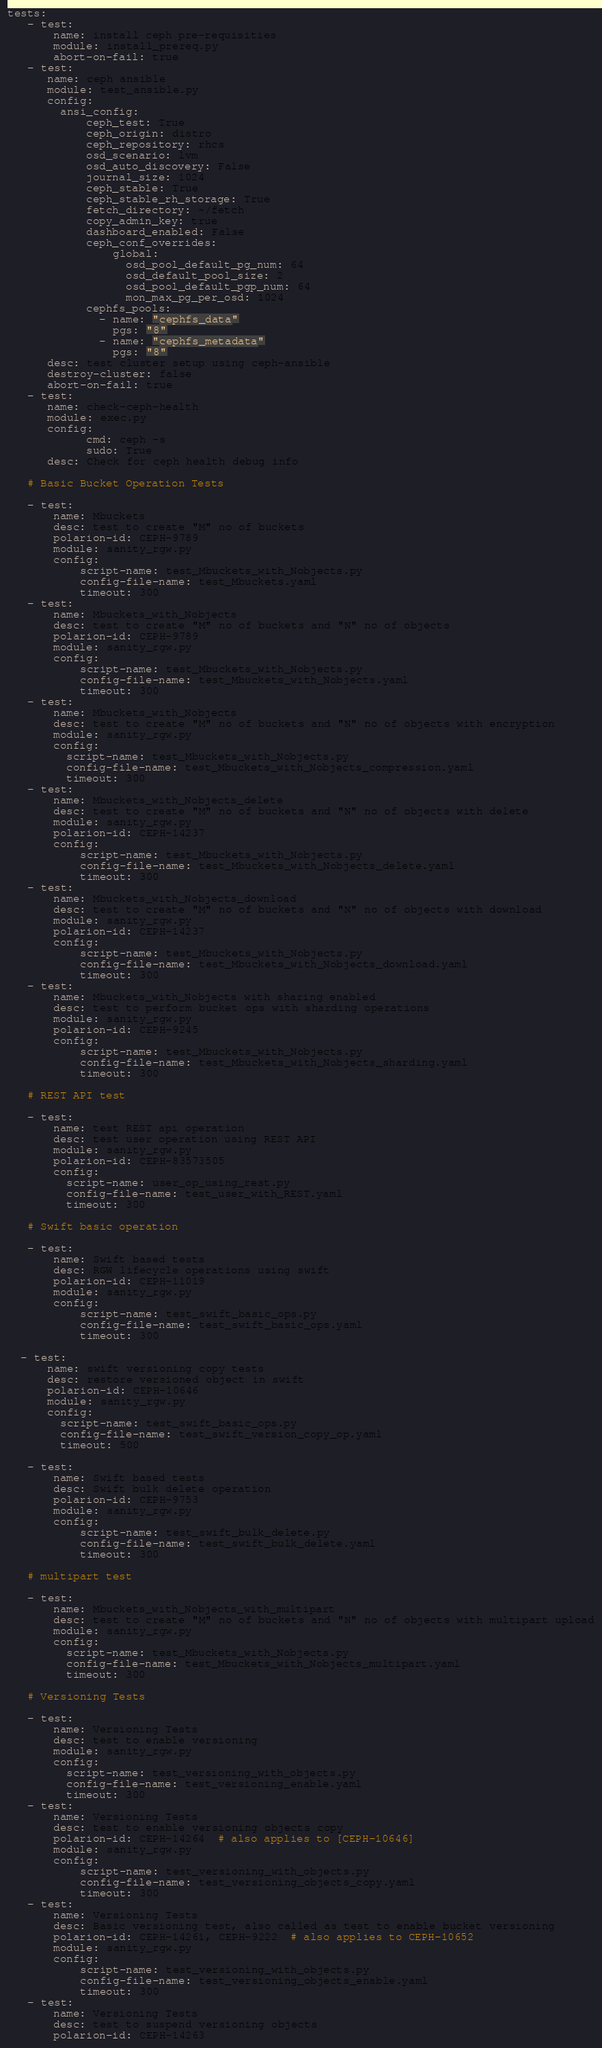Convert code to text. <code><loc_0><loc_0><loc_500><loc_500><_YAML_>tests:
   - test:
       name: install ceph pre-requisities
       module: install_prereq.py
       abort-on-fail: true
   - test:
      name: ceph ansible
      module: test_ansible.py
      config:
        ansi_config:
            ceph_test: True
            ceph_origin: distro
            ceph_repository: rhcs
            osd_scenario: lvm
            osd_auto_discovery: False
            journal_size: 1024
            ceph_stable: True
            ceph_stable_rh_storage: True
            fetch_directory: ~/fetch
            copy_admin_key: true
            dashboard_enabled: False
            ceph_conf_overrides:
                global:
                  osd_pool_default_pg_num: 64
                  osd_default_pool_size: 2
                  osd_pool_default_pgp_num: 64
                  mon_max_pg_per_osd: 1024
            cephfs_pools:
              - name: "cephfs_data"
                pgs: "8"
              - name: "cephfs_metadata"
                pgs: "8"
      desc: test cluster setup using ceph-ansible
      destroy-cluster: false
      abort-on-fail: true
   - test:
      name: check-ceph-health
      module: exec.py
      config:
            cmd: ceph -s
            sudo: True
      desc: Check for ceph health debug info

   # Basic Bucket Operation Tests

   - test:
       name: Mbuckets
       desc: test to create "M" no of buckets
       polarion-id: CEPH-9789
       module: sanity_rgw.py
       config:
           script-name: test_Mbuckets_with_Nobjects.py
           config-file-name: test_Mbuckets.yaml
           timeout: 300
   - test:
       name: Mbuckets_with_Nobjects
       desc: test to create "M" no of buckets and "N" no of objects
       polarion-id: CEPH-9789
       module: sanity_rgw.py
       config:
           script-name: test_Mbuckets_with_Nobjects.py
           config-file-name: test_Mbuckets_with_Nobjects.yaml
           timeout: 300
   - test:
       name: Mbuckets_with_Nobjects
       desc: test to create "M" no of buckets and "N" no of objects with encryption
       module: sanity_rgw.py
       config:
         script-name: test_Mbuckets_with_Nobjects.py
         config-file-name: test_Mbuckets_with_Nobjects_compression.yaml
         timeout: 300
   - test:
       name: Mbuckets_with_Nobjects_delete
       desc: test to create "M" no of buckets and "N" no of objects with delete
       module: sanity_rgw.py
       polarion-id: CEPH-14237
       config:
           script-name: test_Mbuckets_with_Nobjects.py
           config-file-name: test_Mbuckets_with_Nobjects_delete.yaml
           timeout: 300
   - test:
       name: Mbuckets_with_Nobjects_download
       desc: test to create "M" no of buckets and "N" no of objects with download
       module: sanity_rgw.py
       polarion-id: CEPH-14237
       config:
           script-name: test_Mbuckets_with_Nobjects.py
           config-file-name: test_Mbuckets_with_Nobjects_download.yaml
           timeout: 300
   - test:
       name: Mbuckets_with_Nobjects with sharing enabled
       desc: test to perform bucket ops with sharding operations
       module: sanity_rgw.py
       polarion-id: CEPH-9245
       config:
           script-name: test_Mbuckets_with_Nobjects.py
           config-file-name: test_Mbuckets_with_Nobjects_sharding.yaml
           timeout: 300

   # REST API test

   - test:
       name: test REST api operation
       desc: test user operation using REST API
       module: sanity_rgw.py
       polarion-id: CEPH-83573505
       config:
         script-name: user_op_using_rest.py
         config-file-name: test_user_with_REST.yaml
         timeout: 300

   # Swift basic operation

   - test:
       name: Swift based tests
       desc: RGW lifecycle operations using swift
       polarion-id: CEPH-11019
       module: sanity_rgw.py
       config:
           script-name: test_swift_basic_ops.py
           config-file-name: test_swift_basic_ops.yaml
           timeout: 300

  - test:
      name: swift versioning copy tests
      desc: restore versioned object in swift
      polarion-id: CEPH-10646
      module: sanity_rgw.py
      config:
        script-name: test_swift_basic_ops.py
        config-file-name: test_swift_version_copy_op.yaml
        timeout: 500

   - test:
       name: Swift based tests
       desc: Swift bulk delete operation
       polarion-id: CEPH-9753
       module: sanity_rgw.py
       config:
           script-name: test_swift_bulk_delete.py
           config-file-name: test_swift_bulk_delete.yaml
           timeout: 300

   # multipart test

   - test:
       name: Mbuckets_with_Nobjects_with_multipart
       desc: test to create "M" no of buckets and "N" no of objects with multipart upload
       module: sanity_rgw.py
       config:
         script-name: test_Mbuckets_with_Nobjects.py
         config-file-name: test_Mbuckets_with_Nobjects_multipart.yaml
         timeout: 300

   # Versioning Tests

   - test:
       name: Versioning Tests
       desc: test to enable versioning
       module: sanity_rgw.py
       config:
         script-name: test_versioning_with_objects.py
         config-file-name: test_versioning_enable.yaml
         timeout: 300
   - test:
       name: Versioning Tests
       desc: test to enable versioning objects copy
       polarion-id: CEPH-14264  # also applies to [CEPH-10646]
       module: sanity_rgw.py
       config:
           script-name: test_versioning_with_objects.py
           config-file-name: test_versioning_objects_copy.yaml
           timeout: 300
   - test:
       name: Versioning Tests
       desc: Basic versioning test, also called as test to enable bucket versioning
       polarion-id: CEPH-14261, CEPH-9222  # also applies to CEPH-10652
       module: sanity_rgw.py
       config:
           script-name: test_versioning_with_objects.py
           config-file-name: test_versioning_objects_enable.yaml
           timeout: 300
   - test:
       name: Versioning Tests
       desc: test to suspend versioning objects
       polarion-id: CEPH-14263</code> 